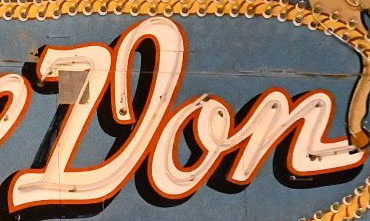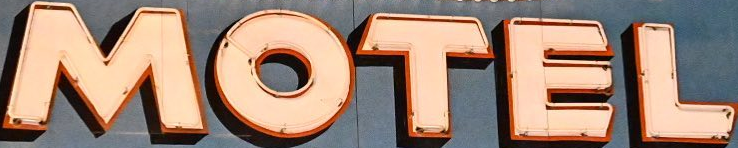Read the text from these images in sequence, separated by a semicolon. Don; MOTEL 